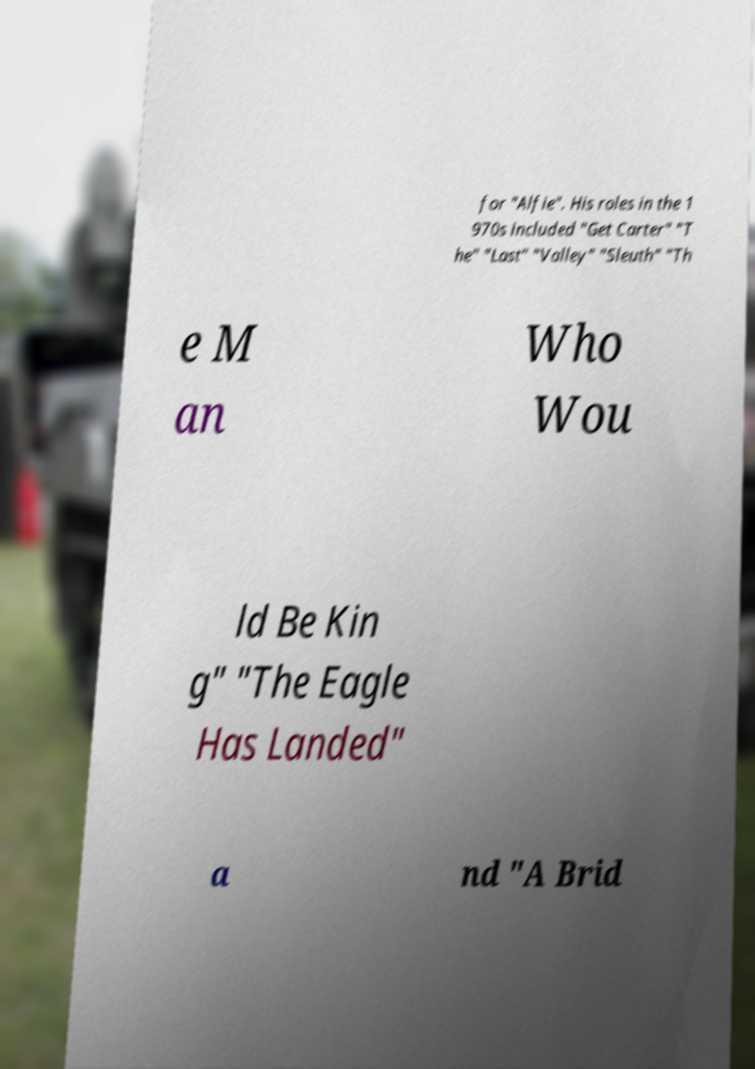I need the written content from this picture converted into text. Can you do that? for "Alfie". His roles in the 1 970s included "Get Carter" "T he" "Last" "Valley" "Sleuth" "Th e M an Who Wou ld Be Kin g" "The Eagle Has Landed" a nd "A Brid 